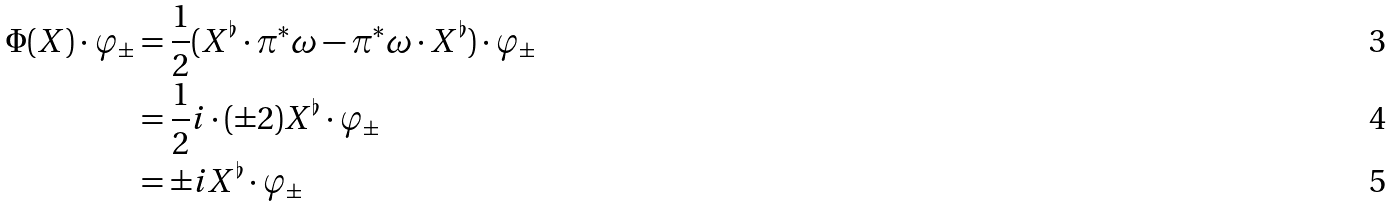Convert formula to latex. <formula><loc_0><loc_0><loc_500><loc_500>\Phi ( X ) \cdot \varphi _ { \pm } & = \frac { 1 } { 2 } ( X ^ { \flat } \cdot \pi ^ { * } \omega - \pi ^ { * } \omega \cdot X ^ { \flat } ) \cdot \varphi _ { \pm } \\ & = \frac { 1 } { 2 } i \cdot ( \pm 2 ) X ^ { \flat } \cdot \varphi _ { \pm } \\ & = \pm i X ^ { \flat } \cdot \varphi _ { \pm }</formula> 